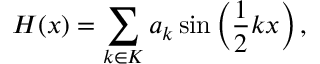Convert formula to latex. <formula><loc_0><loc_0><loc_500><loc_500>H ( x ) = \sum _ { k \in K } a _ { k } \sin \left ( \frac { 1 } { 2 } k x \right ) ,</formula> 